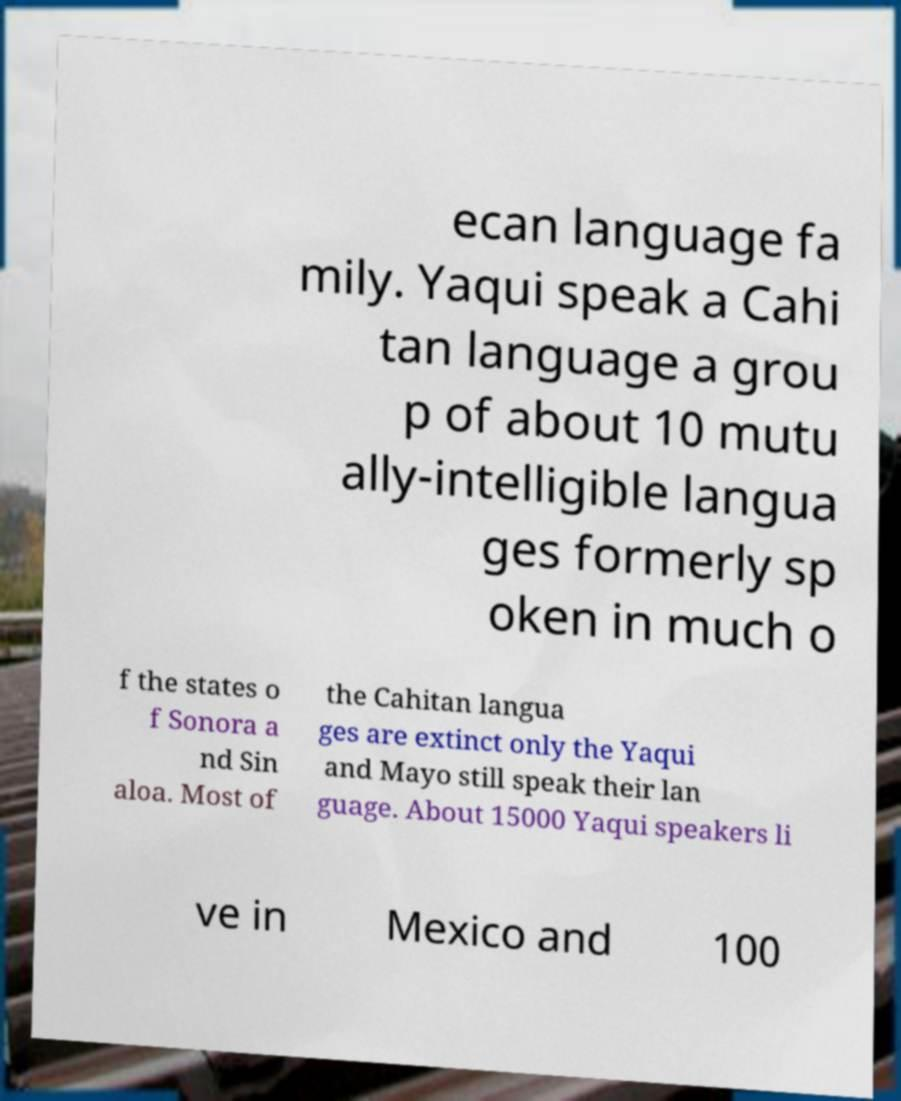Could you extract and type out the text from this image? ecan language fa mily. Yaqui speak a Cahi tan language a grou p of about 10 mutu ally-intelligible langua ges formerly sp oken in much o f the states o f Sonora a nd Sin aloa. Most of the Cahitan langua ges are extinct only the Yaqui and Mayo still speak their lan guage. About 15000 Yaqui speakers li ve in Mexico and 100 